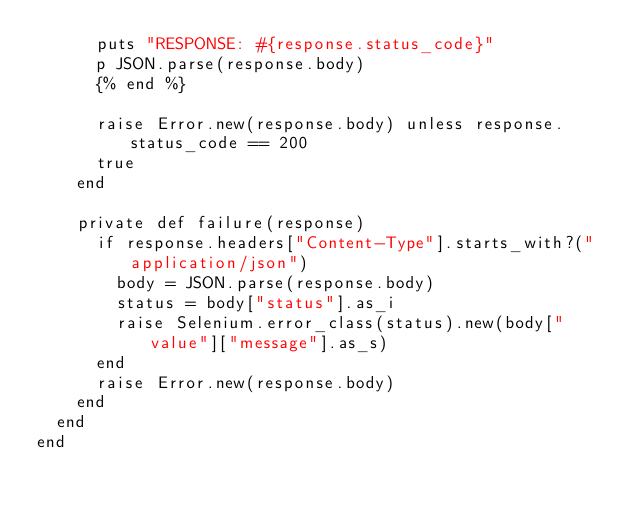<code> <loc_0><loc_0><loc_500><loc_500><_Crystal_>      puts "RESPONSE: #{response.status_code}"
      p JSON.parse(response.body)
      {% end %}

      raise Error.new(response.body) unless response.status_code == 200
      true
    end

    private def failure(response)
      if response.headers["Content-Type"].starts_with?("application/json")
        body = JSON.parse(response.body)
        status = body["status"].as_i
        raise Selenium.error_class(status).new(body["value"]["message"].as_s)
      end
      raise Error.new(response.body)
    end
  end
end
</code> 